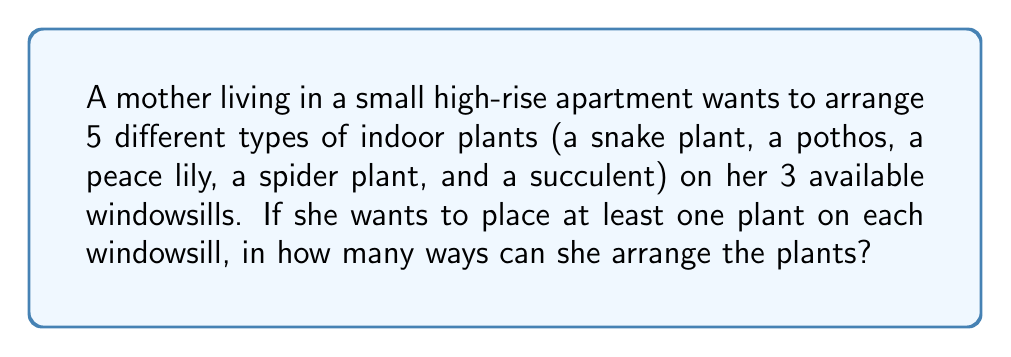Show me your answer to this math problem. Let's approach this step-by-step:

1) First, we need to distribute the 5 plants among the 3 windowsills. This is a partition problem.

2) The possible partitions of 5 objects into 3 non-empty groups are:
   3 + 1 + 1
   2 + 2 + 1

3) For the 3 + 1 + 1 partition:
   - Choose 3 plants for the first windowsill: $\binom{5}{3} = 10$ ways
   - Choose 1 plant for the second windowsill: $\binom{2}{1} = 2$ ways
   - The last plant goes on the third windowsill: 1 way
   - Arrange the windowsills: 3! = 6 ways
   Total for this partition: $10 \times 2 \times 1 \times 6 = 120$ ways

4) For the 2 + 2 + 1 partition:
   - Choose 2 plants for the first windowsill: $\binom{5}{2} = 10$ ways
   - Choose 2 plants for the second windowsill: $\binom{3}{2} = 3$ ways
   - The last plant goes on the third windowsill: 1 way
   - Arrange the windowsills: 3! = 6 ways
   Total for this partition: $10 \times 3 \times 1 \times 6 = 180$ ways

5) The total number of arrangements is the sum of arrangements for both partitions:
   $120 + 180 = 300$

Therefore, there are 300 ways to arrange the plants.
Answer: 300 